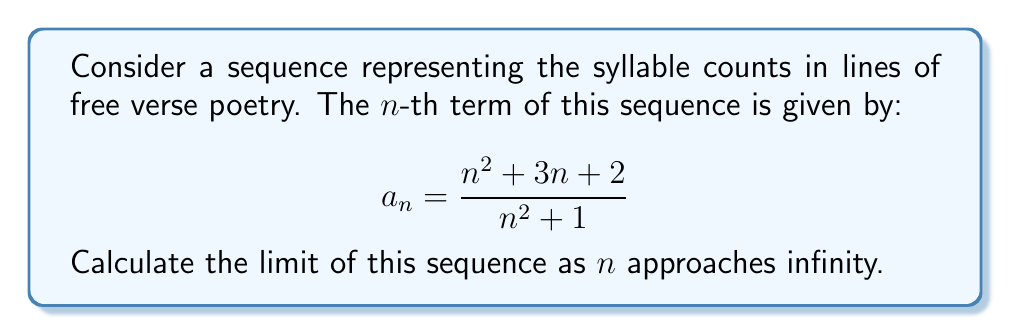Show me your answer to this math problem. To find the limit of this sequence, we'll follow these steps:

1) First, let's examine the general term of the sequence:
   $$a_n = \frac{n^2 + 3n + 2}{n^2 + 1}$$

2) To find the limit as n approaches infinity, we can divide both the numerator and denominator by the highest power of n, which is n^2:
   $$\lim_{n \to \infty} a_n = \lim_{n \to \infty} \frac{n^2 + 3n + 2}{n^2 + 1} = \lim_{n \to \infty} \frac{\frac{n^2}{n^2} + \frac{3n}{n^2} + \frac{2}{n^2}}{\frac{n^2}{n^2} + \frac{1}{n^2}}$$

3) Simplify:
   $$\lim_{n \to \infty} \frac{1 + \frac{3}{n} + \frac{2}{n^2}}{1 + \frac{1}{n^2}}$$

4) As n approaches infinity, $\frac{1}{n}$ and $\frac{1}{n^2}$ approach 0:
   $$\lim_{n \to \infty} \frac{1 + 0 + 0}{1 + 0} = \frac{1}{1} = 1$$

Therefore, the limit of the sequence as n approaches infinity is 1.
Answer: 1 